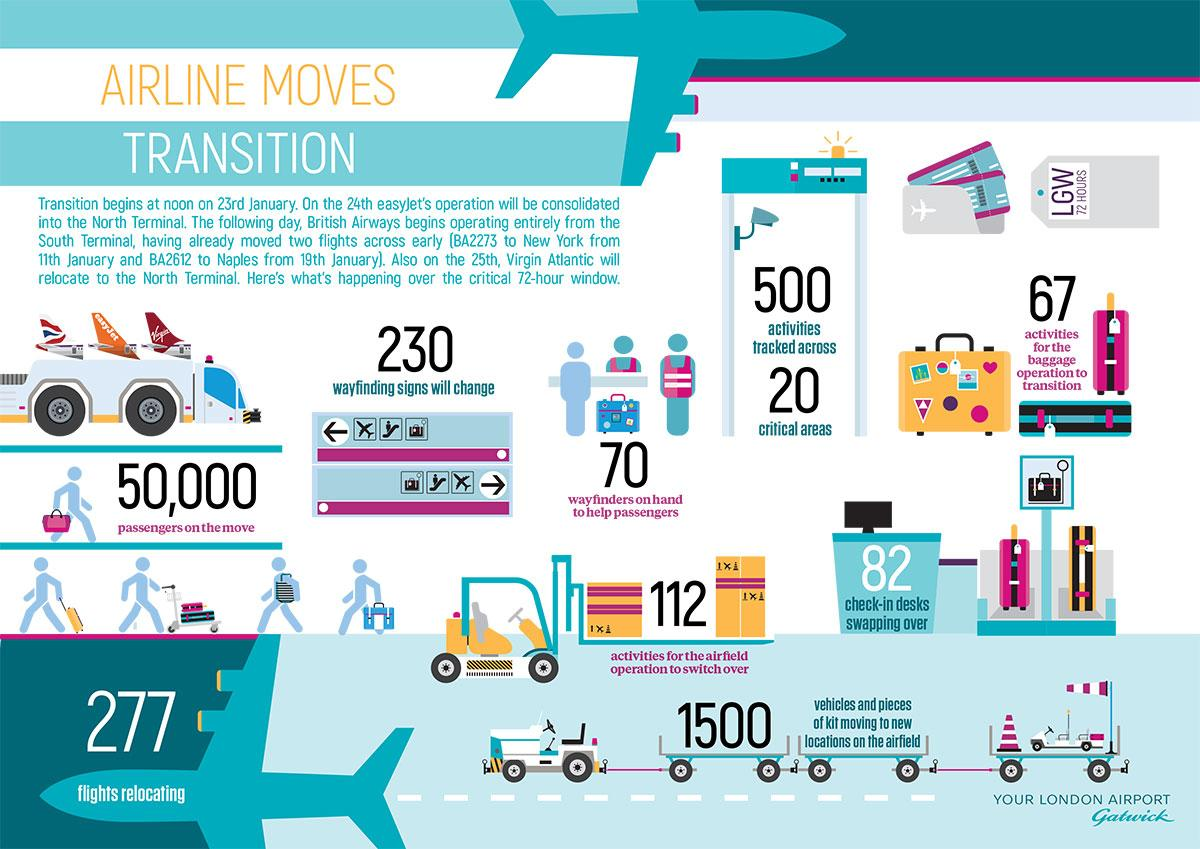Specify some key components in this picture. It is estimated that 277 flights will be relocating. Virgin Atlantic is set to move to the North terminal. During the 72-hour window, 82 check-in desks will be swapping over. Seven zero wayfinders will be available to assist passengers during the critical 72-hour time frame. 